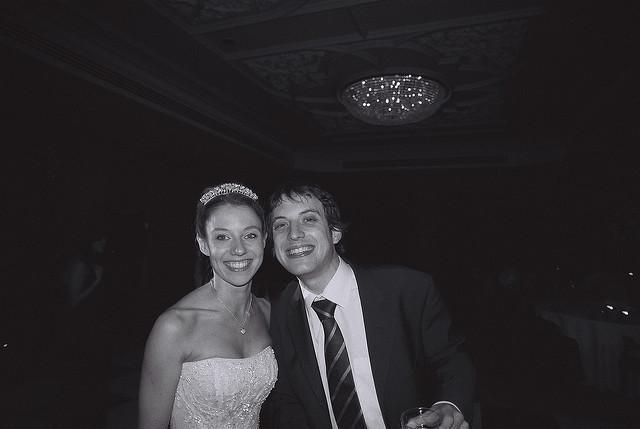How many people are visible?
Give a very brief answer. 3. How many sinks are to the right of the shower?
Give a very brief answer. 0. 